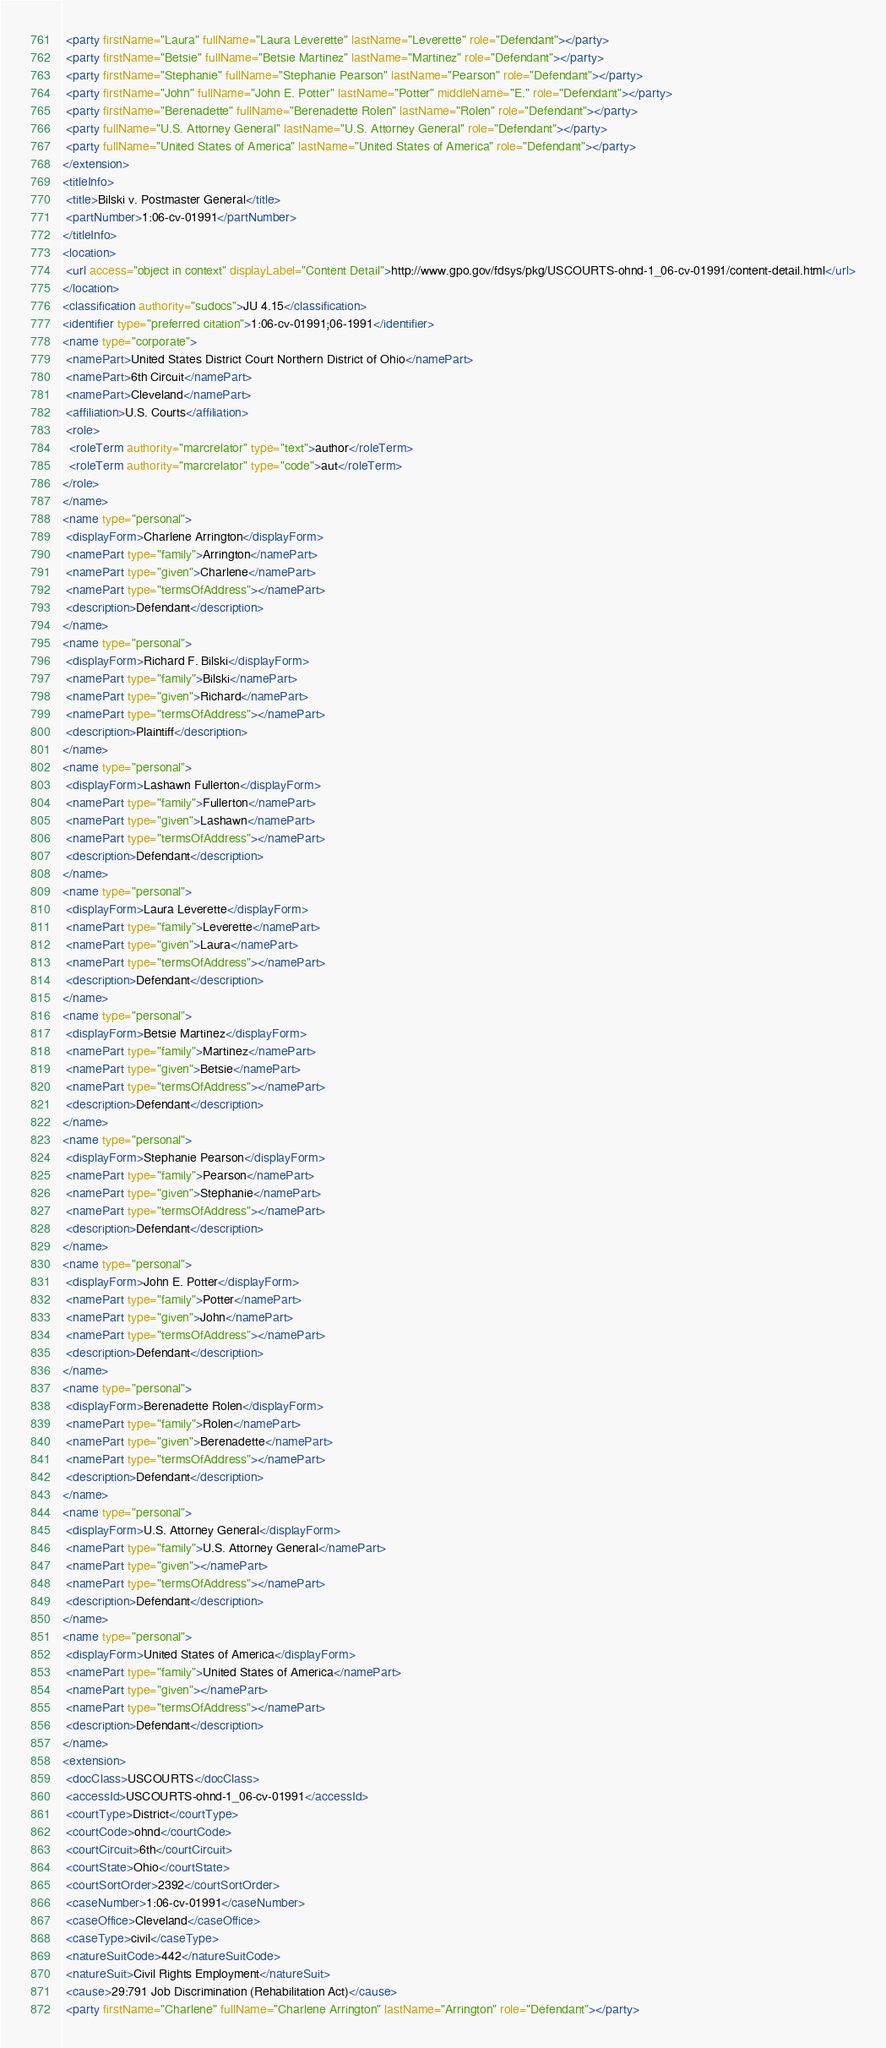Convert code to text. <code><loc_0><loc_0><loc_500><loc_500><_XML_> <party firstName="Laura" fullName="Laura Leverette" lastName="Leverette" role="Defendant"></party>
 <party firstName="Betsie" fullName="Betsie Martinez" lastName="Martinez" role="Defendant"></party>
 <party firstName="Stephanie" fullName="Stephanie Pearson" lastName="Pearson" role="Defendant"></party>
 <party firstName="John" fullName="John E. Potter" lastName="Potter" middleName="E." role="Defendant"></party>
 <party firstName="Berenadette" fullName="Berenadette Rolen" lastName="Rolen" role="Defendant"></party>
 <party fullName="U.S. Attorney General" lastName="U.S. Attorney General" role="Defendant"></party>
 <party fullName="United States of America" lastName="United States of America" role="Defendant"></party>
</extension>
<titleInfo>
 <title>Bilski v. Postmaster General</title>
 <partNumber>1:06-cv-01991</partNumber>
</titleInfo>
<location>
 <url access="object in context" displayLabel="Content Detail">http://www.gpo.gov/fdsys/pkg/USCOURTS-ohnd-1_06-cv-01991/content-detail.html</url>
</location>
<classification authority="sudocs">JU 4.15</classification>
<identifier type="preferred citation">1:06-cv-01991;06-1991</identifier>
<name type="corporate">
 <namePart>United States District Court Northern District of Ohio</namePart>
 <namePart>6th Circuit</namePart>
 <namePart>Cleveland</namePart>
 <affiliation>U.S. Courts</affiliation>
 <role>
  <roleTerm authority="marcrelator" type="text">author</roleTerm>
  <roleTerm authority="marcrelator" type="code">aut</roleTerm>
</role>
</name>
<name type="personal">
 <displayForm>Charlene Arrington</displayForm>
 <namePart type="family">Arrington</namePart>
 <namePart type="given">Charlene</namePart>
 <namePart type="termsOfAddress"></namePart>
 <description>Defendant</description>
</name>
<name type="personal">
 <displayForm>Richard F. Bilski</displayForm>
 <namePart type="family">Bilski</namePart>
 <namePart type="given">Richard</namePart>
 <namePart type="termsOfAddress"></namePart>
 <description>Plaintiff</description>
</name>
<name type="personal">
 <displayForm>Lashawn Fullerton</displayForm>
 <namePart type="family">Fullerton</namePart>
 <namePart type="given">Lashawn</namePart>
 <namePart type="termsOfAddress"></namePart>
 <description>Defendant</description>
</name>
<name type="personal">
 <displayForm>Laura Leverette</displayForm>
 <namePart type="family">Leverette</namePart>
 <namePart type="given">Laura</namePart>
 <namePart type="termsOfAddress"></namePart>
 <description>Defendant</description>
</name>
<name type="personal">
 <displayForm>Betsie Martinez</displayForm>
 <namePart type="family">Martinez</namePart>
 <namePart type="given">Betsie</namePart>
 <namePart type="termsOfAddress"></namePart>
 <description>Defendant</description>
</name>
<name type="personal">
 <displayForm>Stephanie Pearson</displayForm>
 <namePart type="family">Pearson</namePart>
 <namePart type="given">Stephanie</namePart>
 <namePart type="termsOfAddress"></namePart>
 <description>Defendant</description>
</name>
<name type="personal">
 <displayForm>John E. Potter</displayForm>
 <namePart type="family">Potter</namePart>
 <namePart type="given">John</namePart>
 <namePart type="termsOfAddress"></namePart>
 <description>Defendant</description>
</name>
<name type="personal">
 <displayForm>Berenadette Rolen</displayForm>
 <namePart type="family">Rolen</namePart>
 <namePart type="given">Berenadette</namePart>
 <namePart type="termsOfAddress"></namePart>
 <description>Defendant</description>
</name>
<name type="personal">
 <displayForm>U.S. Attorney General</displayForm>
 <namePart type="family">U.S. Attorney General</namePart>
 <namePart type="given"></namePart>
 <namePart type="termsOfAddress"></namePart>
 <description>Defendant</description>
</name>
<name type="personal">
 <displayForm>United States of America</displayForm>
 <namePart type="family">United States of America</namePart>
 <namePart type="given"></namePart>
 <namePart type="termsOfAddress"></namePart>
 <description>Defendant</description>
</name>
<extension>
 <docClass>USCOURTS</docClass>
 <accessId>USCOURTS-ohnd-1_06-cv-01991</accessId>
 <courtType>District</courtType>
 <courtCode>ohnd</courtCode>
 <courtCircuit>6th</courtCircuit>
 <courtState>Ohio</courtState>
 <courtSortOrder>2392</courtSortOrder>
 <caseNumber>1:06-cv-01991</caseNumber>
 <caseOffice>Cleveland</caseOffice>
 <caseType>civil</caseType>
 <natureSuitCode>442</natureSuitCode>
 <natureSuit>Civil Rights Employment</natureSuit>
 <cause>29:791 Job Discrimination (Rehabilitation Act)</cause>
 <party firstName="Charlene" fullName="Charlene Arrington" lastName="Arrington" role="Defendant"></party></code> 